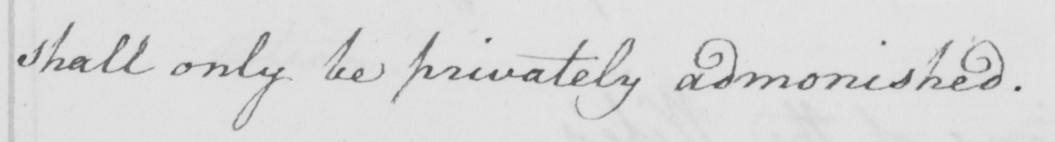What text is written in this handwritten line? shall only be privately admonished . 